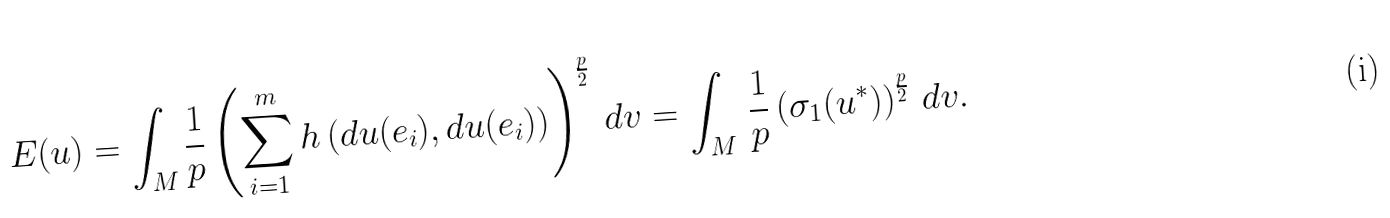Convert formula to latex. <formula><loc_0><loc_0><loc_500><loc_500>E ( u ) = \int _ { M } \frac { 1 } { p } \left ( \sum _ { i = 1 } ^ { m } h \left ( d u ( e _ { i } ) , d u ( e _ { i } ) \right ) \right ) ^ { \frac { p } { 2 } } \, d v = \int _ { M } \, \frac { 1 } { p } \left ( { \sigma _ { 1 } } ( u ^ { \ast } ) \right ) ^ { \frac { p } { 2 } } \, d v .</formula> 